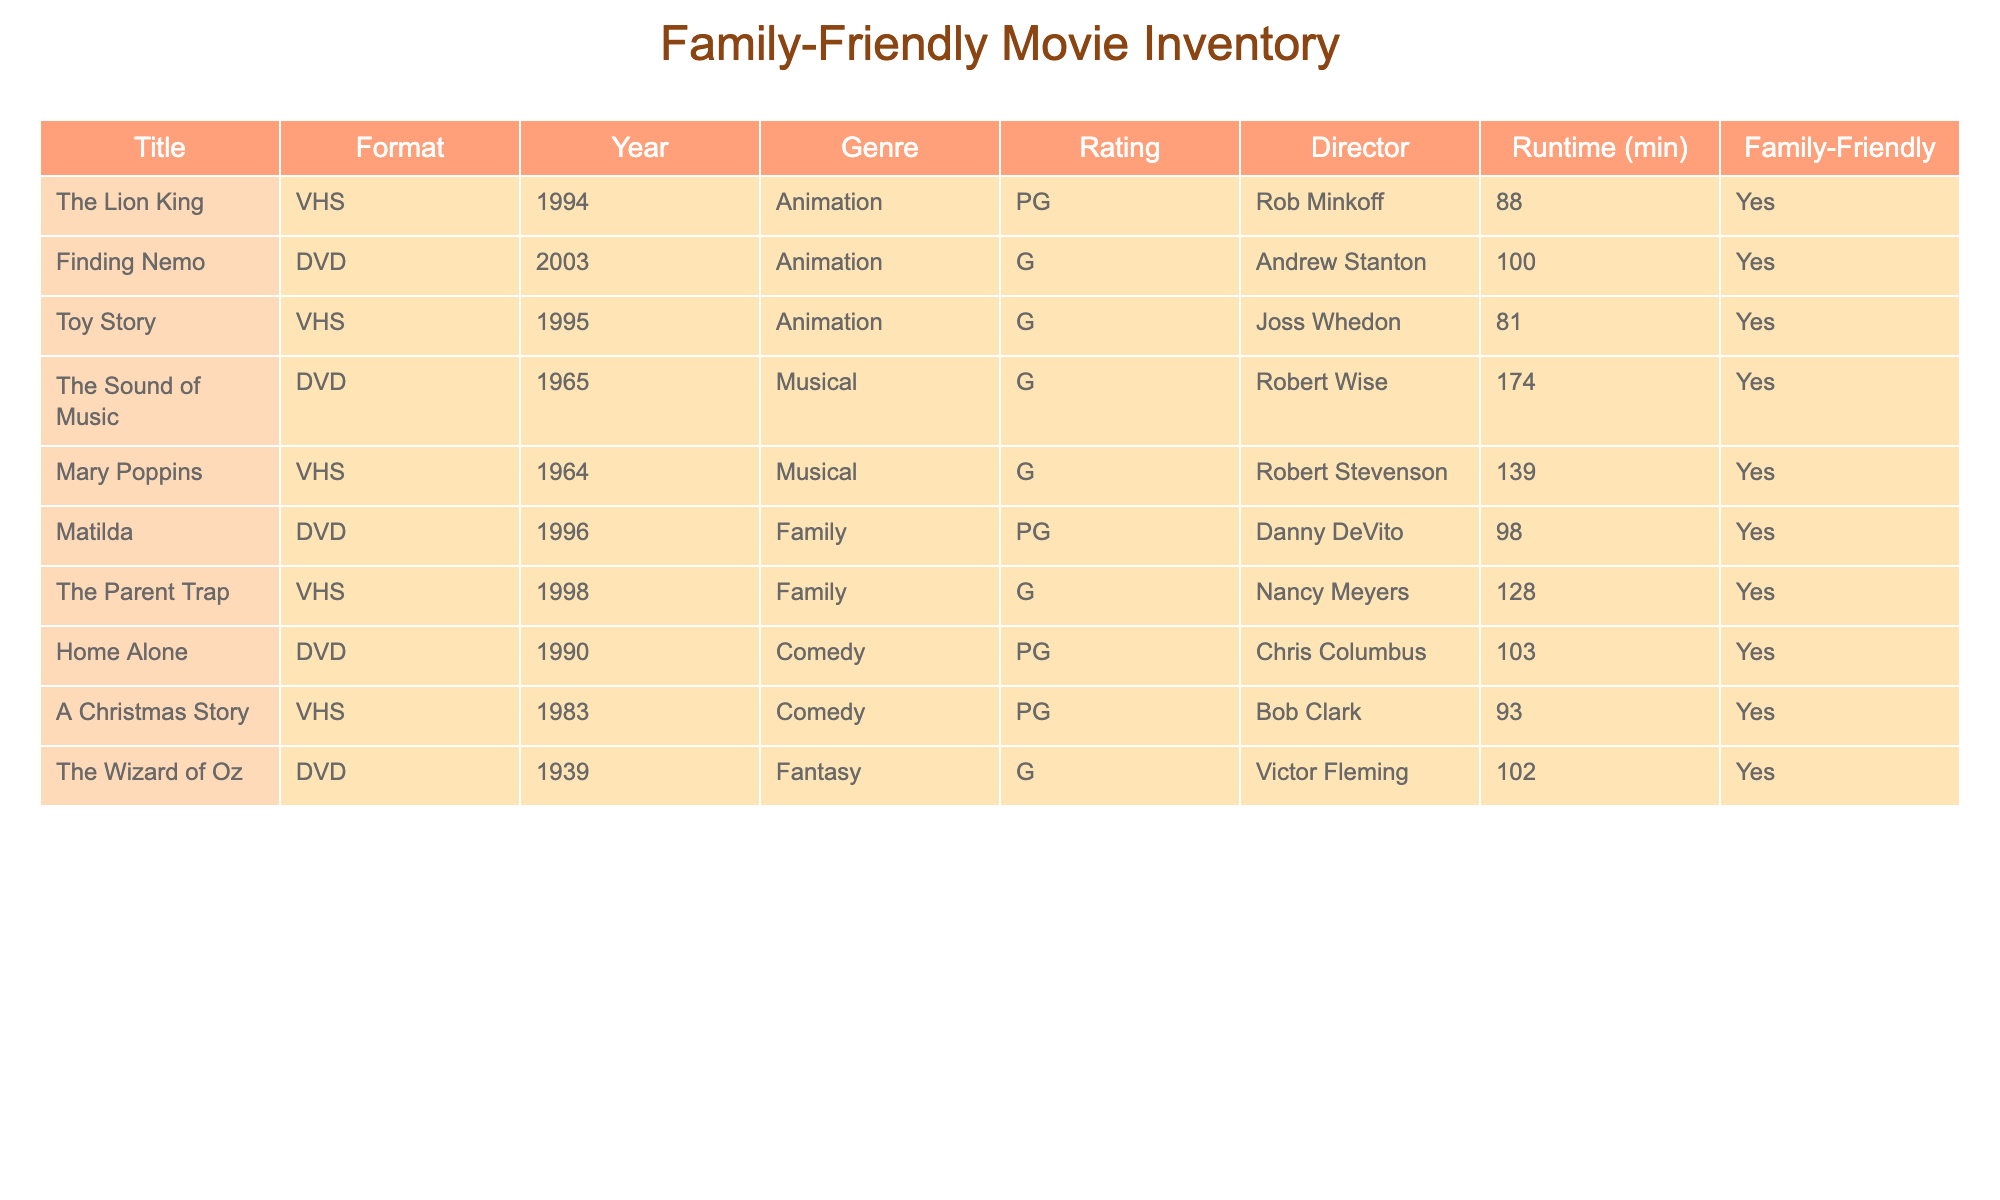What year was The Lion King released? The table shows the year of release for each movie, and for The Lion King, it is listed under the Year column as 1994.
Answer: 1994 Which format is Matilda available in? In the table, under the Format column, Matilda is listed as available in DVD format.
Answer: DVD Is Home Alone a family-friendly movie? The Family-Friendly column indicates whether a movie is family-friendly or not. Home Alone's entry is marked as Yes, meaning it is family-friendly.
Answer: Yes How many minutes long is The Sound of Music? The runtime of The Sound of Music is found in the Runtime (min) column, which is noted as 174 minutes long.
Answer: 174 Which movie has the longest runtime among the titles listed? To determine the longest runtime, we compare the runtimes: The Sound of Music (174), Mary Poppins (139), and others. The maximum runtime is 174 minutes from The Sound of Music.
Answer: The Sound of Music How many animated films are in the inventory? The genre of each entry can be checked, and by counting the number of entries labeled "Animation," we find three: The Lion King, Finding Nemo, and Toy Story.
Answer: 3 Does the table include any films released after 2000? By reviewing the Year column, only Finding Nemo from 2003 falls after 2000, while other films have earlier release years, mitigating this query's scope.
Answer: Yes What is the average runtime of all family-friendly movies listed? To find the average, we first identify family-friendly films: all titles are family-friendly (9 total). The sum of their runtimes is 88 + 100 + 81 + 174 + 139 + 98 + 128 + 103 + 102 = 1014 minutes. Dividing 1014 by 9 gives an average runtime of approximately 112.67 minutes.
Answer: 112.67 How many movies directed by Robert Wise are listed? The table marks two titles directed by Robert Wise: The Sound of Music. Upon counting, there is only one movie.
Answer: 1 